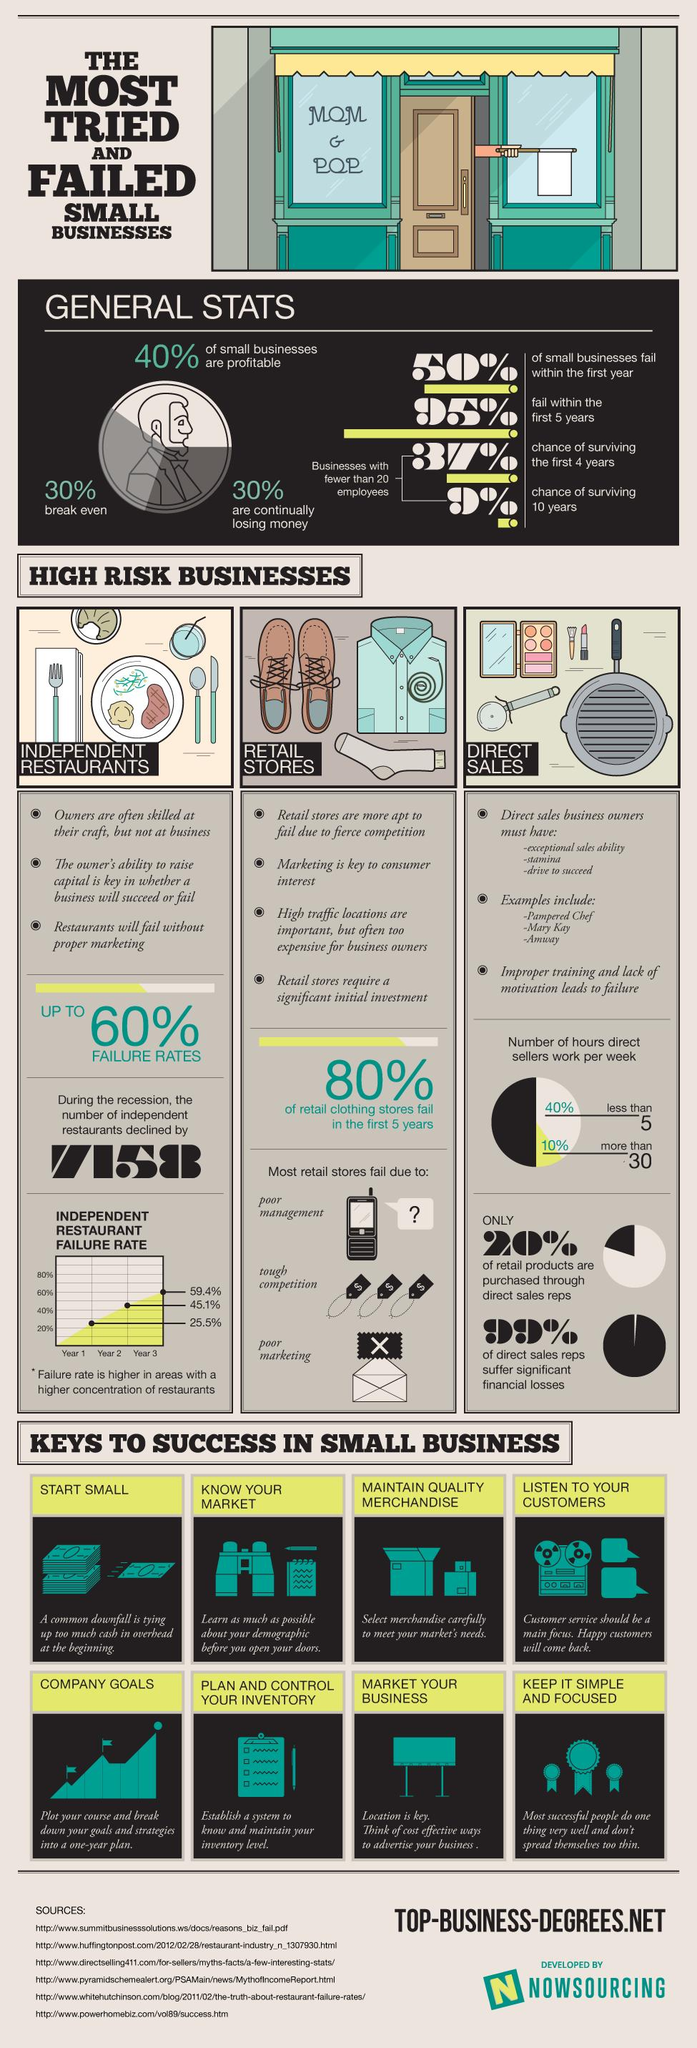List a handful of essential elements in this visual. The list of keys to success in small business contains 8 tips. The failure of retail stores is attributed to multiple reasons, with three being particularly significant. 